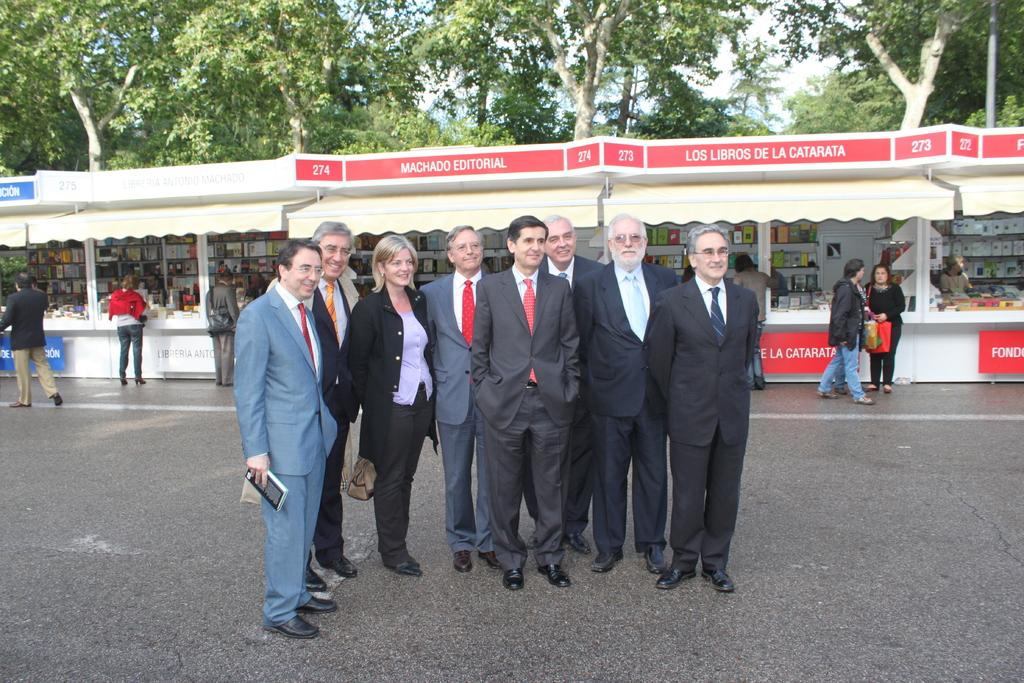What are the people in the image doing? The people in the image are standing on a road. What can be seen in the background of the image? There are stalls in the background. Are there any people near the stalls? Yes, there are people standing near the stalls. What type of vegetation is visible behind the stalls? Trees are visible behind the stalls. What type of bean is being used to fold the clothes in the image? There is no bean or folding of clothes present in the image. 